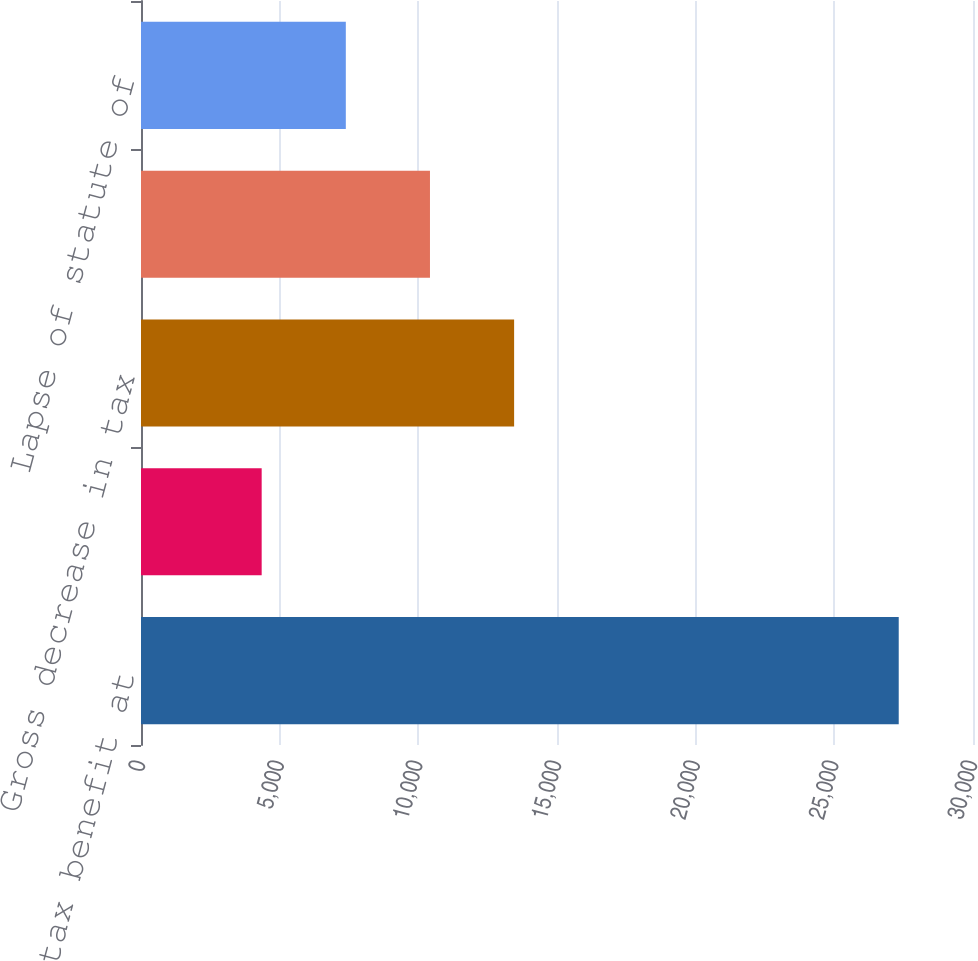Convert chart to OTSL. <chart><loc_0><loc_0><loc_500><loc_500><bar_chart><fcel>Unrecognized tax benefit at<fcel>Gross increase in tax<fcel>Gross decrease in tax<fcel>Settlements<fcel>Lapse of statute of<nl><fcel>27322<fcel>4351.2<fcel>13453.8<fcel>10419.6<fcel>7385.4<nl></chart> 